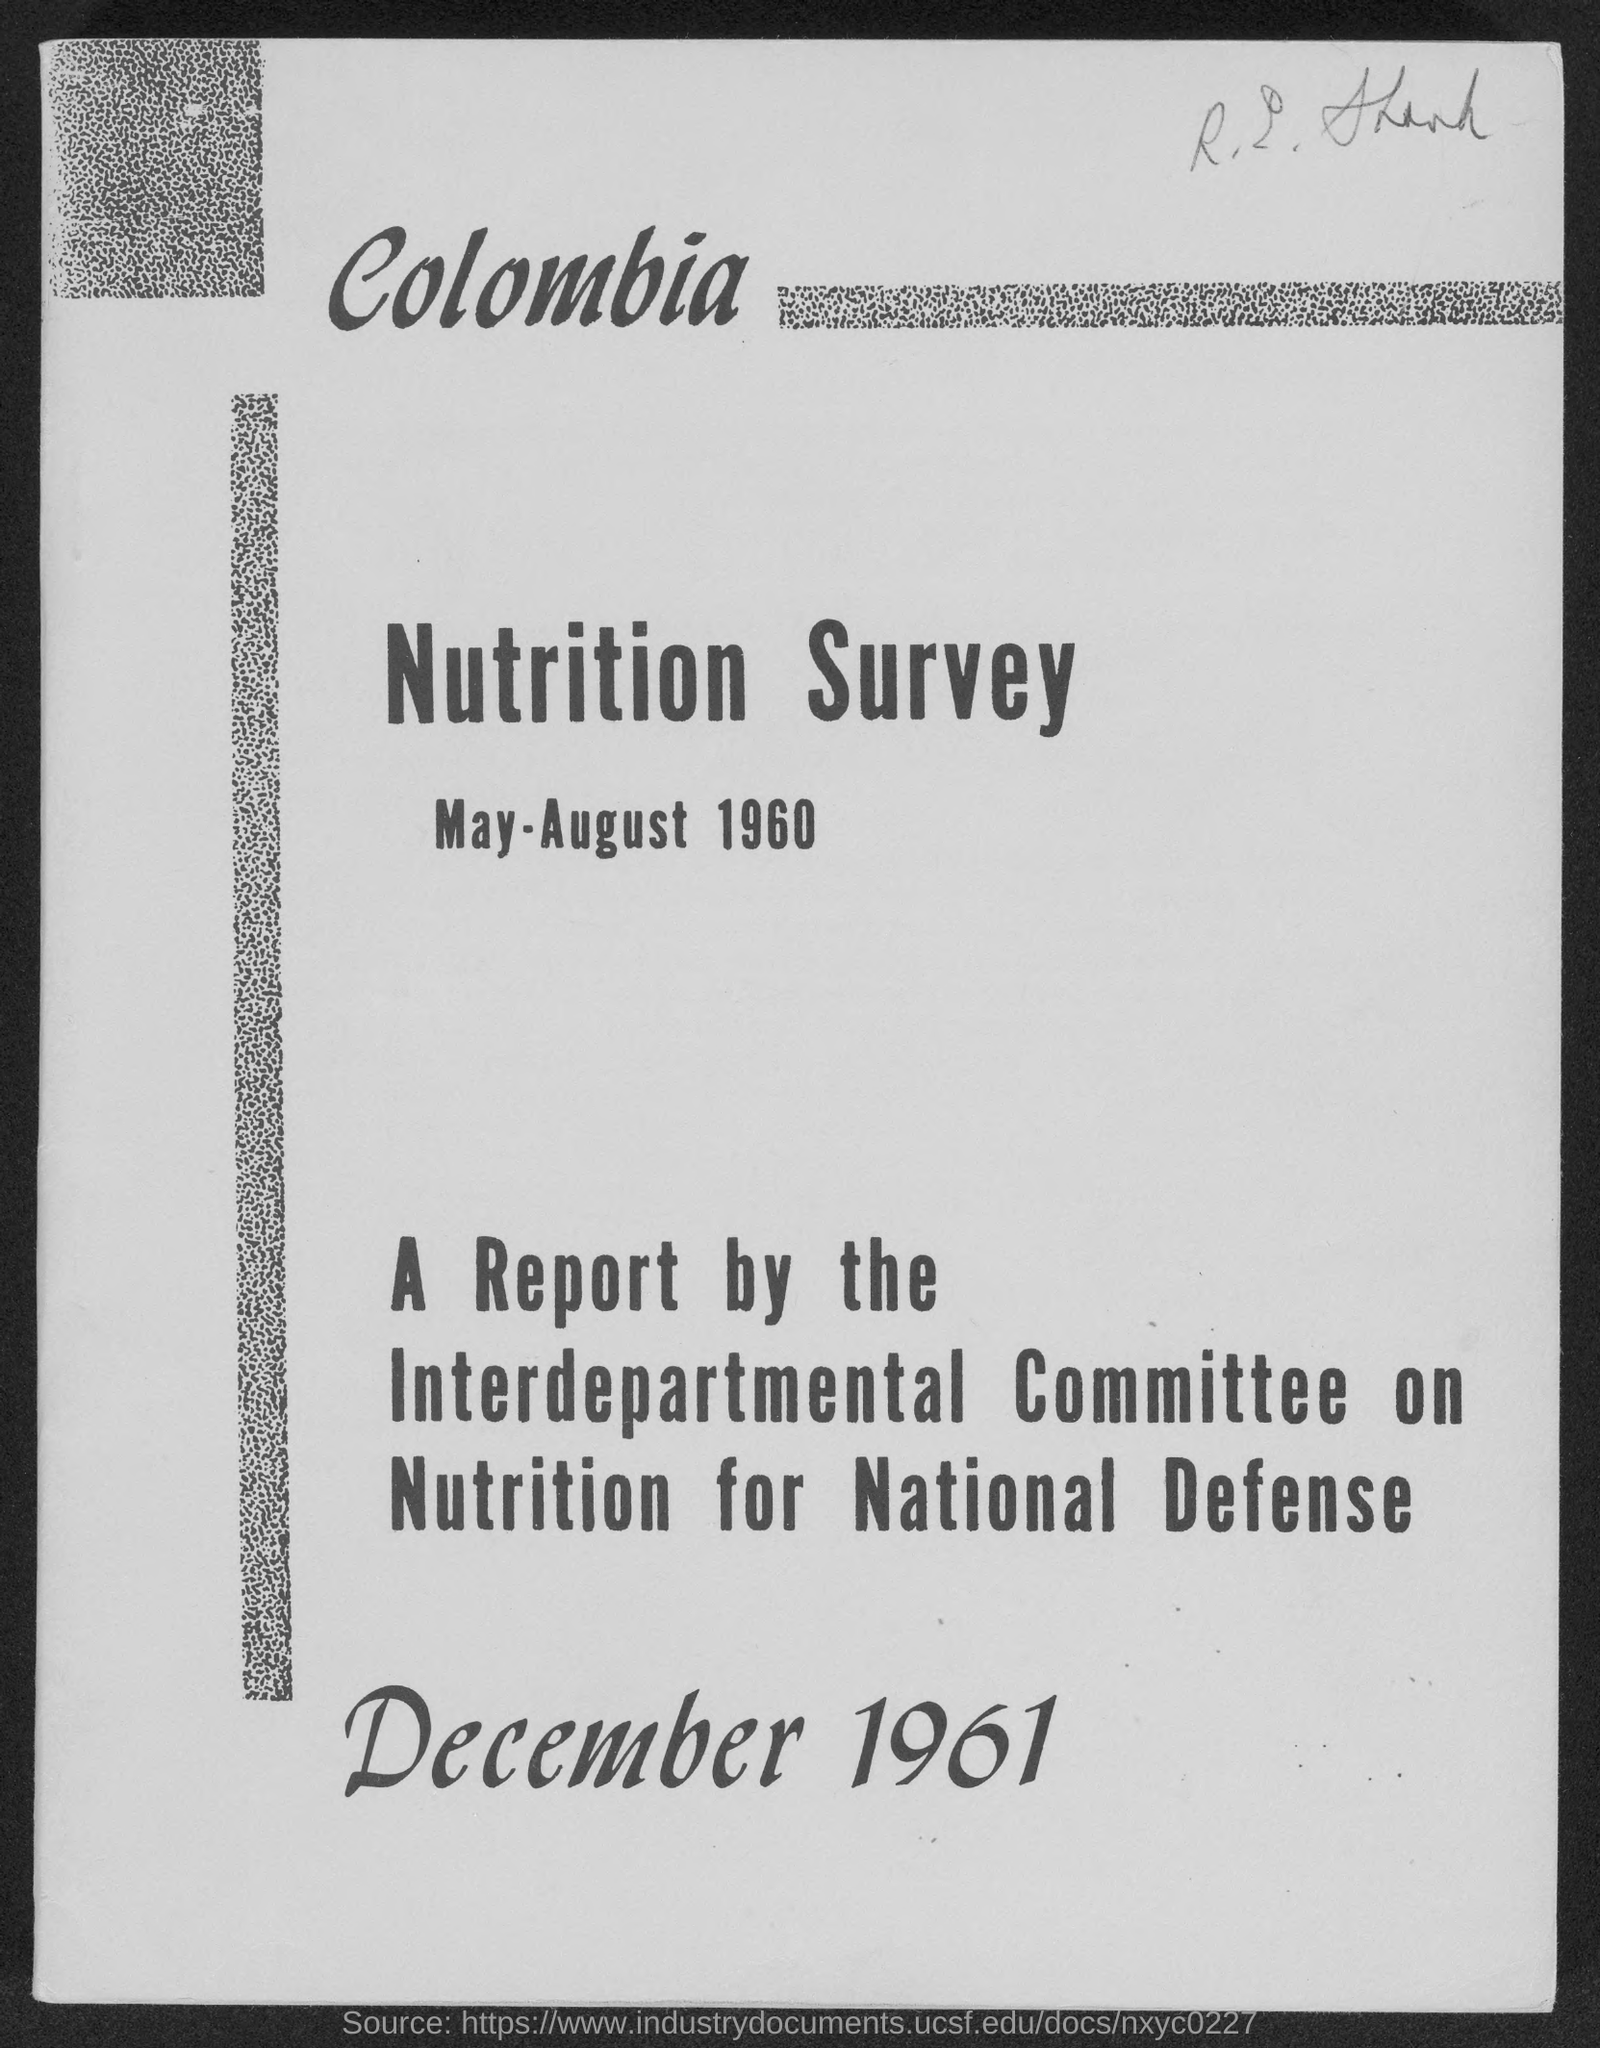Identify some key points in this picture. The date of the report is December 1961. The nutrition survey was conducted from May to August 1960. 